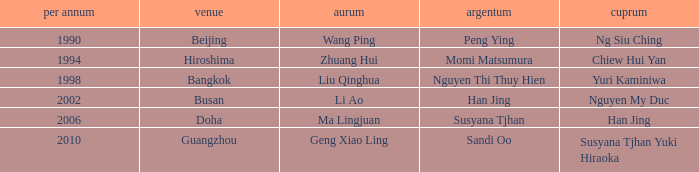What Silver has the Location of Guangzhou? Sandi Oo. 